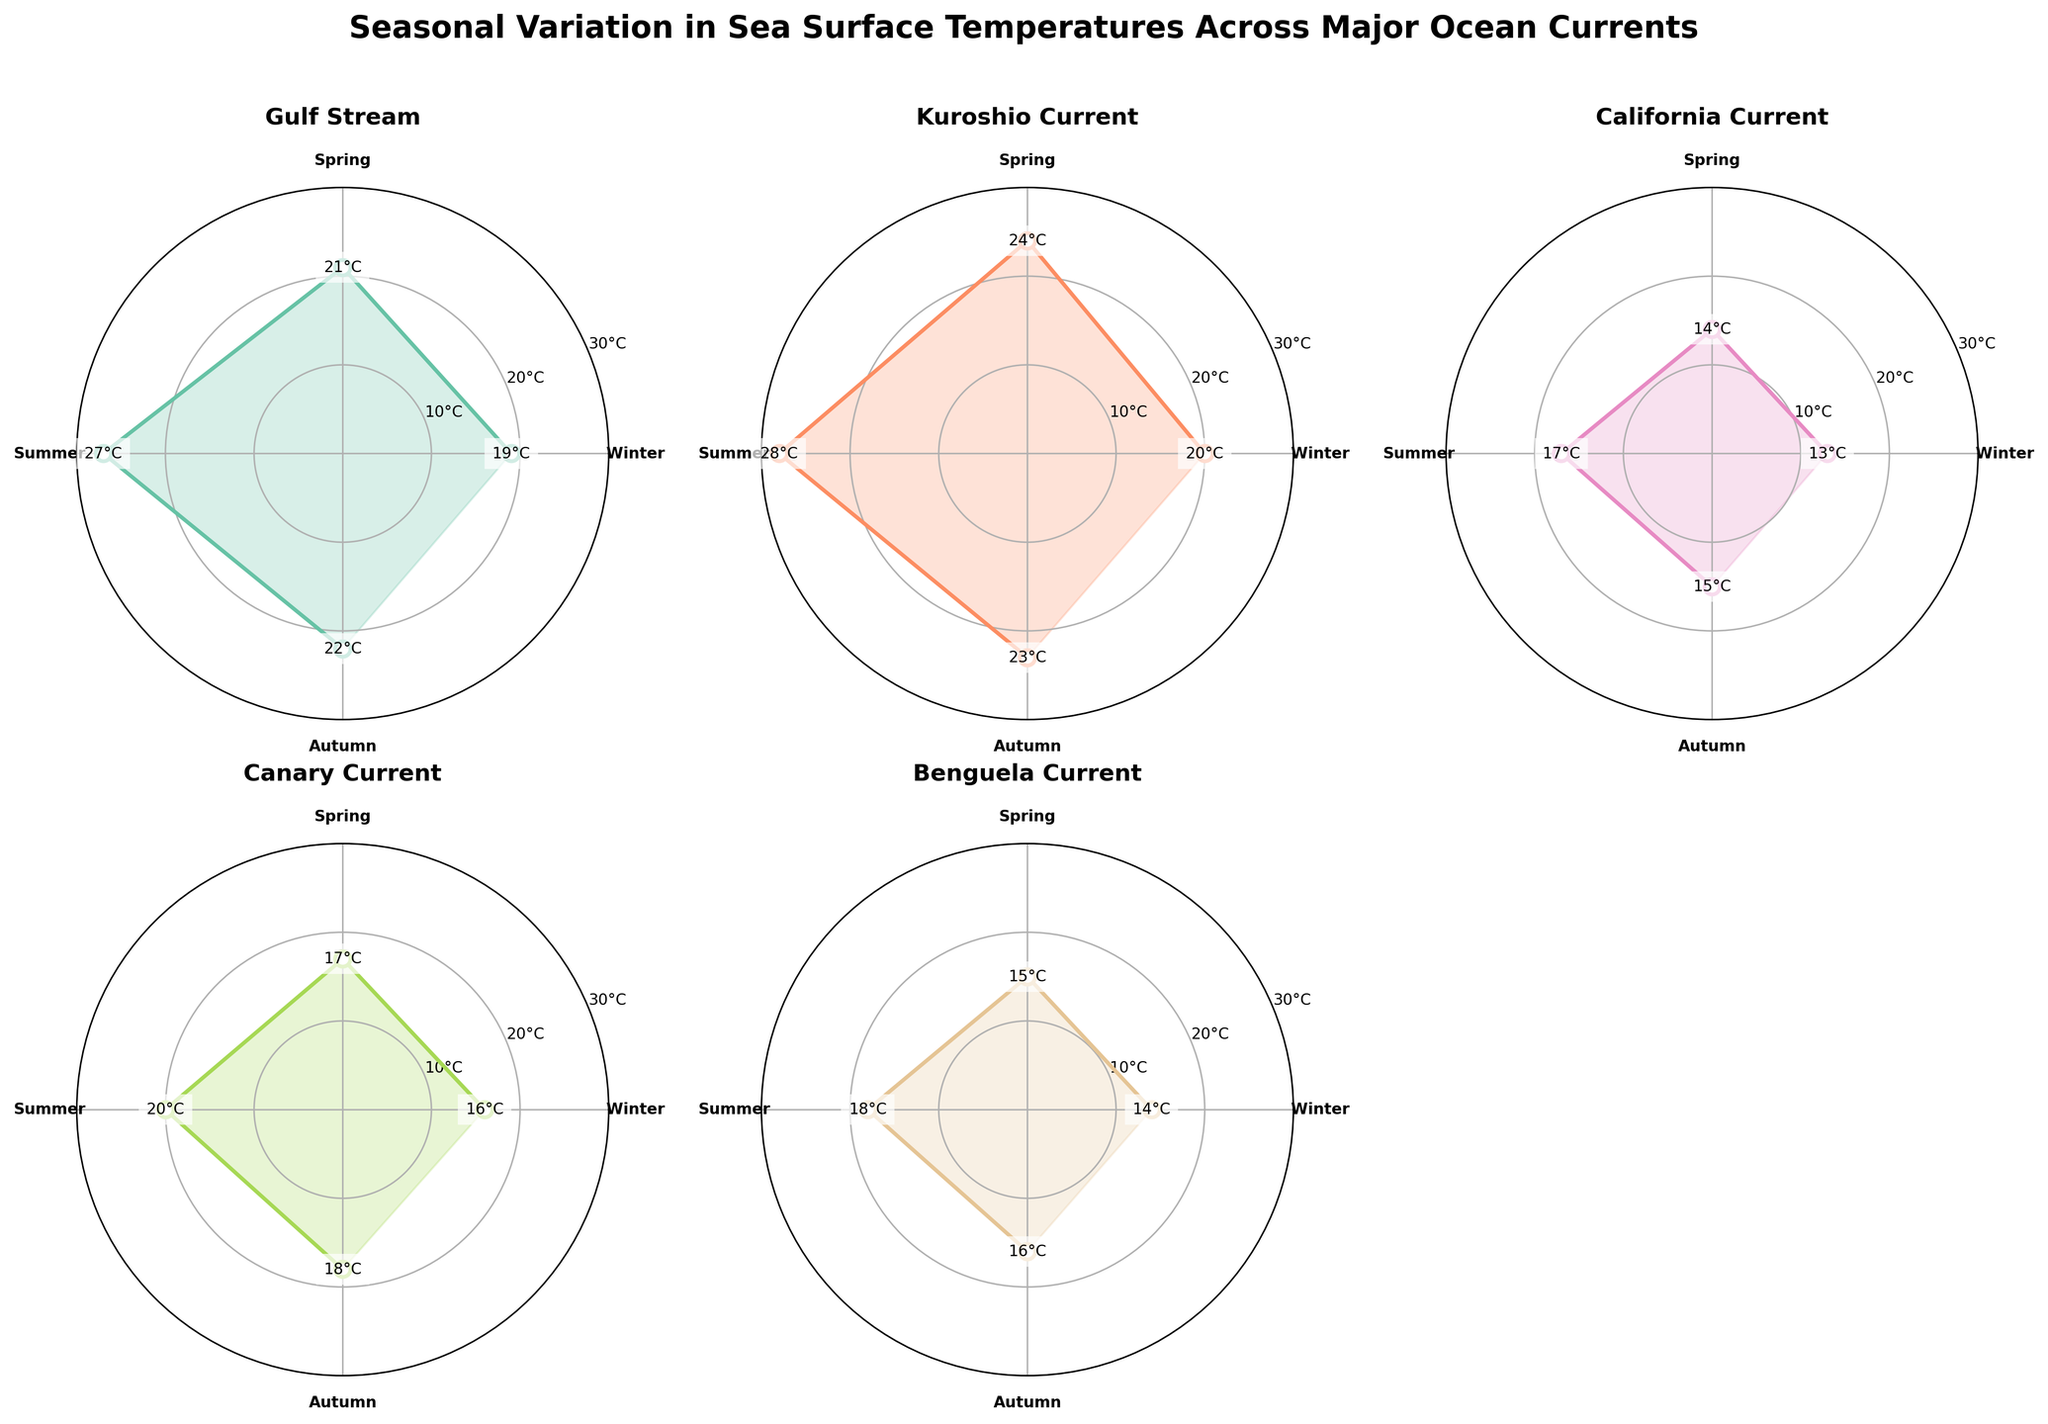What is the title of the entire figure? The title of the figure is usually displayed prominently at the top as the heading, and in this case, it is "Seasonal Variation in Sea Surface Temperatures Across Major Ocean Currents."
Answer: Seasonal Variation in Sea Surface Temperatures Across Major Ocean Currents Which ocean current has the highest sea surface temperature in Winter? To find the highest sea surface temperature for Winter, look at the Winter data points across each polar chart. The highest temperature (20°C) is seen in the Kuroshio Current.
Answer: Kuroshio Current What is the seasonal trend for the Gulf Stream's sea surface temperatures? Observing the Gulf Stream polar chart, the temperatures increase from Winter (19°C) to Spring (21°C), peak in Summer (27°C), and then decrease in Autumn (22°C).
Answer: Increasing from Winter to Summer and decreasing in Autumn Compared to the Gulf Stream, how does the summer temperature of the California Current differ? The Gulf Stream shows a summer temperature of 27°C, while the California Current shows 17°C. The difference is 27°C - 17°C = 10°C.
Answer: 10°C lower How many data points are plotted for each ocean current? Each ocean current subplot has one data point for each season (Winter, Spring, Summer, and Autumn), resulting in a total of four data points per ocean current.
Answer: Four data points Which season typically shows the highest sea surface temperatures across all ocean currents? Observing all subplots, the Summer season generally shows the highest sea surface temperatures for each ocean current.
Answer: Summer Is there any ocean current where the temperature in Winter is higher than in Autumn? For each polar chart, compare Winter and Autumn temperatures. The Gulf Stream and Kuroshio Current have Winter temperatures (19°C and 20°C respectively) lower than their Autumn temperatures (22°C and 23°C respectively). None have Winter temperatures higher than in Autumn.
Answer: No Which ocean current shows the least temperature variation across seasons? By comparing the range of temperatures in each polar chart, it's evident that the California Current shows the least variation, with temperatures ranging from 13°C to 17°C (a 4°C difference).
Answer: California Current What is the approximate difference in sea surface temperature between the Kuroshio Current and the Benguela Current during Autumn? The Kuroshio Current has an Autumn temperature of 23°C, and the Benguela Current has an Autumn temperature of 16°C. The difference is 23°C - 16°C = 7°C.
Answer: 7°C Which ocean current has the highest cumulative temperature across all seasons? Sum the temperatures for all seasons for each ocean current. Gulf Stream: 19+21+27+22=89°C, Kuroshio Current: 20+24+28+23=95°C, California Current: 13+14+17+15=59°C, Canary Current: 16+17+20+18=71°C, Benguela Current: 14+15+18+16=63°C. The highest cumulative temperature is for the Kuroshio Current.
Answer: Kuroshio Current 